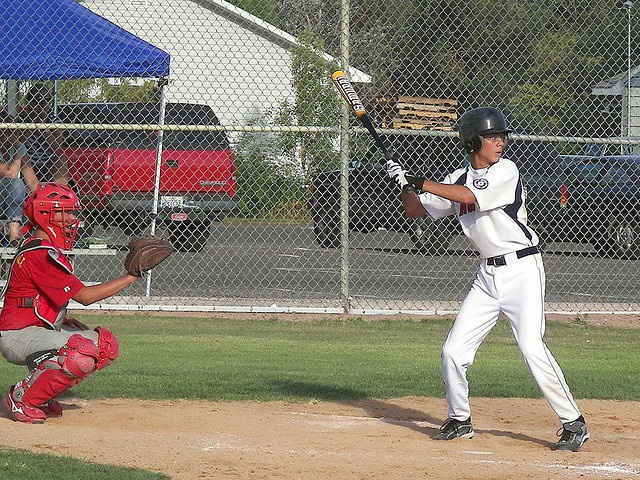Describe the objects in this image and their specific colors. I can see people in blue, white, black, gray, and darkgray tones, car in blue, black, gray, darkgray, and brown tones, people in blue, brown, maroon, and darkgray tones, car in blue, black, gray, darkgray, and lightgray tones, and car in blue, black, gray, darkgray, and lightgray tones in this image. 